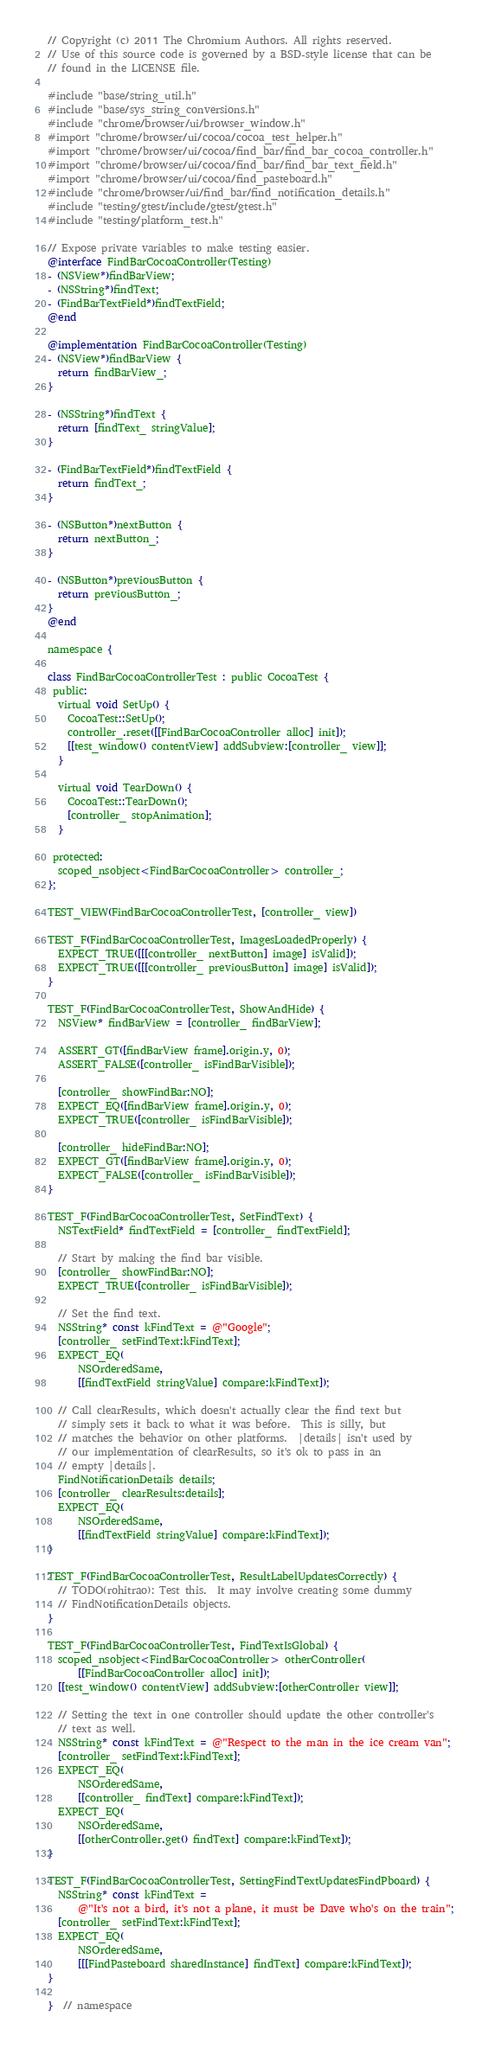<code> <loc_0><loc_0><loc_500><loc_500><_ObjectiveC_>// Copyright (c) 2011 The Chromium Authors. All rights reserved.
// Use of this source code is governed by a BSD-style license that can be
// found in the LICENSE file.

#include "base/string_util.h"
#include "base/sys_string_conversions.h"
#include "chrome/browser/ui/browser_window.h"
#import "chrome/browser/ui/cocoa/cocoa_test_helper.h"
#import "chrome/browser/ui/cocoa/find_bar/find_bar_cocoa_controller.h"
#import "chrome/browser/ui/cocoa/find_bar/find_bar_text_field.h"
#import "chrome/browser/ui/cocoa/find_pasteboard.h"
#include "chrome/browser/ui/find_bar/find_notification_details.h"
#include "testing/gtest/include/gtest/gtest.h"
#include "testing/platform_test.h"

// Expose private variables to make testing easier.
@interface FindBarCocoaController(Testing)
- (NSView*)findBarView;
- (NSString*)findText;
- (FindBarTextField*)findTextField;
@end

@implementation FindBarCocoaController(Testing)
- (NSView*)findBarView {
  return findBarView_;
}

- (NSString*)findText {
  return [findText_ stringValue];
}

- (FindBarTextField*)findTextField {
  return findText_;
}

- (NSButton*)nextButton {
  return nextButton_;
}

- (NSButton*)previousButton {
  return previousButton_;
}
@end

namespace {

class FindBarCocoaControllerTest : public CocoaTest {
 public:
  virtual void SetUp() {
    CocoaTest::SetUp();
    controller_.reset([[FindBarCocoaController alloc] init]);
    [[test_window() contentView] addSubview:[controller_ view]];
  }

  virtual void TearDown() {
    CocoaTest::TearDown();
    [controller_ stopAnimation];
  }

 protected:
  scoped_nsobject<FindBarCocoaController> controller_;
};

TEST_VIEW(FindBarCocoaControllerTest, [controller_ view])

TEST_F(FindBarCocoaControllerTest, ImagesLoadedProperly) {
  EXPECT_TRUE([[[controller_ nextButton] image] isValid]);
  EXPECT_TRUE([[[controller_ previousButton] image] isValid]);
}

TEST_F(FindBarCocoaControllerTest, ShowAndHide) {
  NSView* findBarView = [controller_ findBarView];

  ASSERT_GT([findBarView frame].origin.y, 0);
  ASSERT_FALSE([controller_ isFindBarVisible]);

  [controller_ showFindBar:NO];
  EXPECT_EQ([findBarView frame].origin.y, 0);
  EXPECT_TRUE([controller_ isFindBarVisible]);

  [controller_ hideFindBar:NO];
  EXPECT_GT([findBarView frame].origin.y, 0);
  EXPECT_FALSE([controller_ isFindBarVisible]);
}

TEST_F(FindBarCocoaControllerTest, SetFindText) {
  NSTextField* findTextField = [controller_ findTextField];

  // Start by making the find bar visible.
  [controller_ showFindBar:NO];
  EXPECT_TRUE([controller_ isFindBarVisible]);

  // Set the find text.
  NSString* const kFindText = @"Google";
  [controller_ setFindText:kFindText];
  EXPECT_EQ(
      NSOrderedSame,
      [[findTextField stringValue] compare:kFindText]);

  // Call clearResults, which doesn't actually clear the find text but
  // simply sets it back to what it was before.  This is silly, but
  // matches the behavior on other platforms.  |details| isn't used by
  // our implementation of clearResults, so it's ok to pass in an
  // empty |details|.
  FindNotificationDetails details;
  [controller_ clearResults:details];
  EXPECT_EQ(
      NSOrderedSame,
      [[findTextField stringValue] compare:kFindText]);
}

TEST_F(FindBarCocoaControllerTest, ResultLabelUpdatesCorrectly) {
  // TODO(rohitrao): Test this.  It may involve creating some dummy
  // FindNotificationDetails objects.
}

TEST_F(FindBarCocoaControllerTest, FindTextIsGlobal) {
  scoped_nsobject<FindBarCocoaController> otherController(
      [[FindBarCocoaController alloc] init]);
  [[test_window() contentView] addSubview:[otherController view]];

  // Setting the text in one controller should update the other controller's
  // text as well.
  NSString* const kFindText = @"Respect to the man in the ice cream van";
  [controller_ setFindText:kFindText];
  EXPECT_EQ(
      NSOrderedSame,
      [[controller_ findText] compare:kFindText]);
  EXPECT_EQ(
      NSOrderedSame,
      [[otherController.get() findText] compare:kFindText]);
}

TEST_F(FindBarCocoaControllerTest, SettingFindTextUpdatesFindPboard) {
  NSString* const kFindText =
      @"It's not a bird, it's not a plane, it must be Dave who's on the train";
  [controller_ setFindText:kFindText];
  EXPECT_EQ(
      NSOrderedSame,
      [[[FindPasteboard sharedInstance] findText] compare:kFindText]);
}

}  // namespace
</code> 